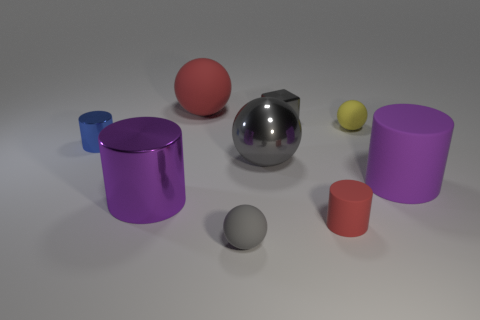What size is the matte cylinder that is the same color as the large rubber ball?
Your response must be concise. Small. There is a matte thing that is the same color as the large metal cylinder; what is its shape?
Make the answer very short. Cylinder. What is the material of the other tiny object that is the same shape as the blue thing?
Your response must be concise. Rubber. The small sphere that is in front of the yellow rubber thing is what color?
Provide a succinct answer. Gray. Are there more tiny rubber balls on the right side of the tiny gray rubber thing than yellow cylinders?
Your answer should be compact. Yes. The big metal cylinder has what color?
Your answer should be very brief. Purple. What shape is the tiny gray thing that is to the right of the gray sphere that is in front of the metallic object in front of the large metal sphere?
Your response must be concise. Cube. There is a large thing that is on the right side of the large red matte object and to the left of the small red matte thing; what material is it?
Ensure brevity in your answer.  Metal. There is a red matte thing that is in front of the red object that is left of the tiny gray matte thing; what shape is it?
Ensure brevity in your answer.  Cylinder. Are there any other things that are the same color as the tiny metallic cylinder?
Provide a succinct answer. No. 